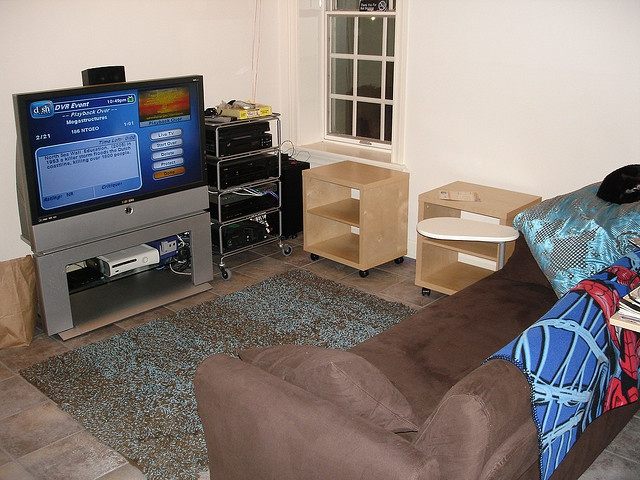Describe the objects in this image and their specific colors. I can see couch in darkgray, gray, maroon, and black tones, tv in darkgray, black, gray, navy, and blue tones, book in darkgray, tan, olive, and gold tones, and remote in darkgray, gray, and white tones in this image. 